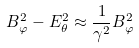Convert formula to latex. <formula><loc_0><loc_0><loc_500><loc_500>B _ { \varphi } ^ { 2 } - E _ { \theta } ^ { 2 } \approx \frac { 1 } { \gamma ^ { 2 } } B _ { \varphi } ^ { 2 }</formula> 